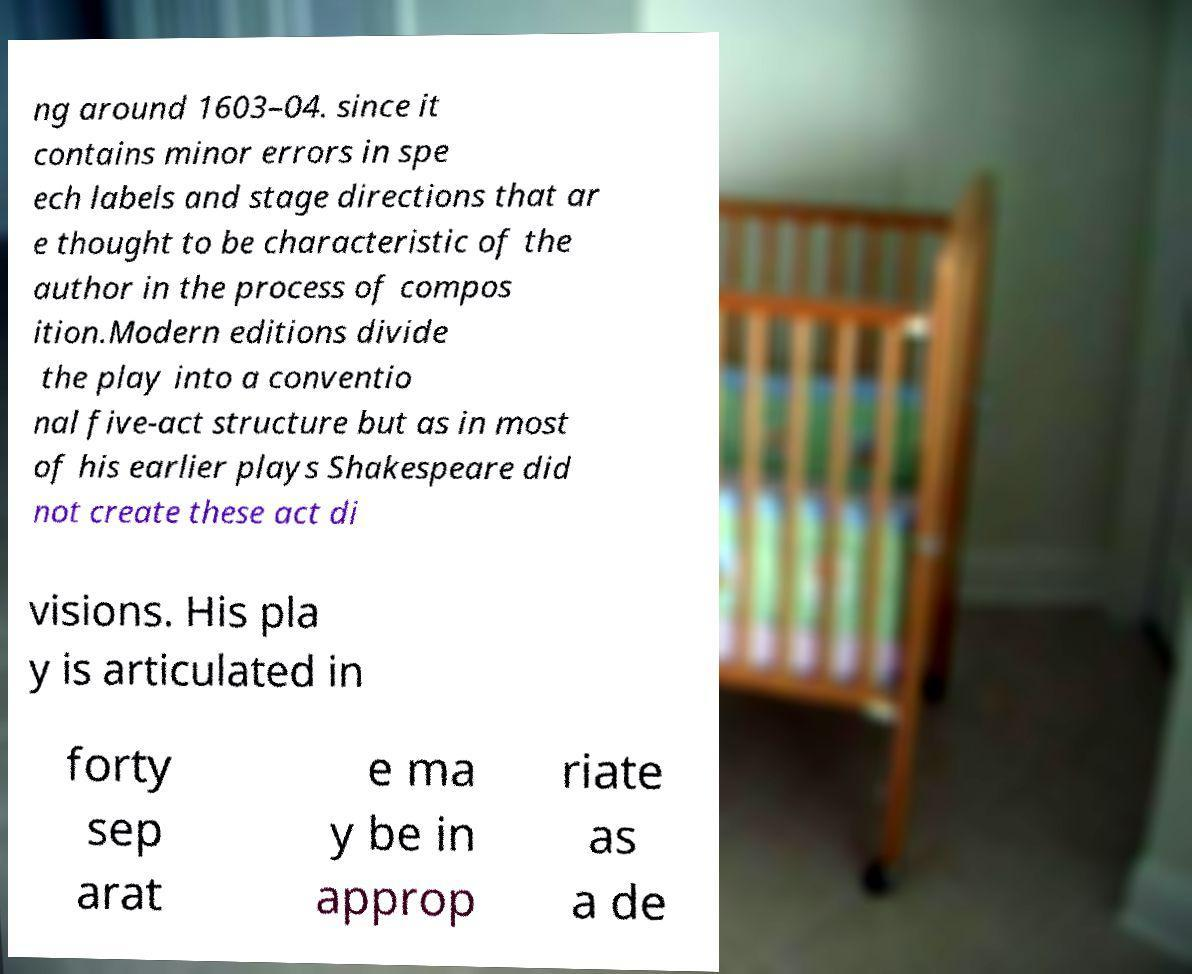Please identify and transcribe the text found in this image. ng around 1603–04. since it contains minor errors in spe ech labels and stage directions that ar e thought to be characteristic of the author in the process of compos ition.Modern editions divide the play into a conventio nal five-act structure but as in most of his earlier plays Shakespeare did not create these act di visions. His pla y is articulated in forty sep arat e ma y be in approp riate as a de 